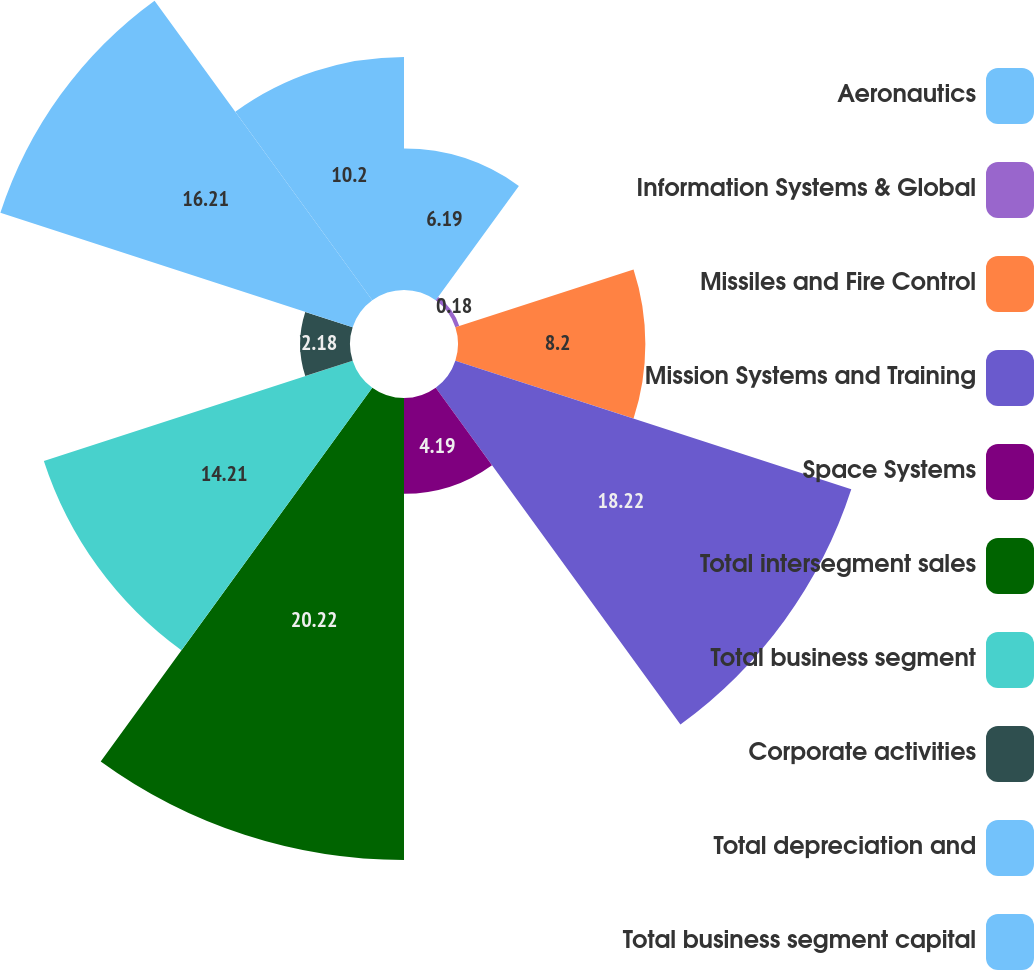Convert chart. <chart><loc_0><loc_0><loc_500><loc_500><pie_chart><fcel>Aeronautics<fcel>Information Systems & Global<fcel>Missiles and Fire Control<fcel>Mission Systems and Training<fcel>Space Systems<fcel>Total intersegment sales<fcel>Total business segment<fcel>Corporate activities<fcel>Total depreciation and<fcel>Total business segment capital<nl><fcel>6.19%<fcel>0.18%<fcel>8.2%<fcel>18.22%<fcel>4.19%<fcel>20.22%<fcel>14.21%<fcel>2.18%<fcel>16.21%<fcel>10.2%<nl></chart> 